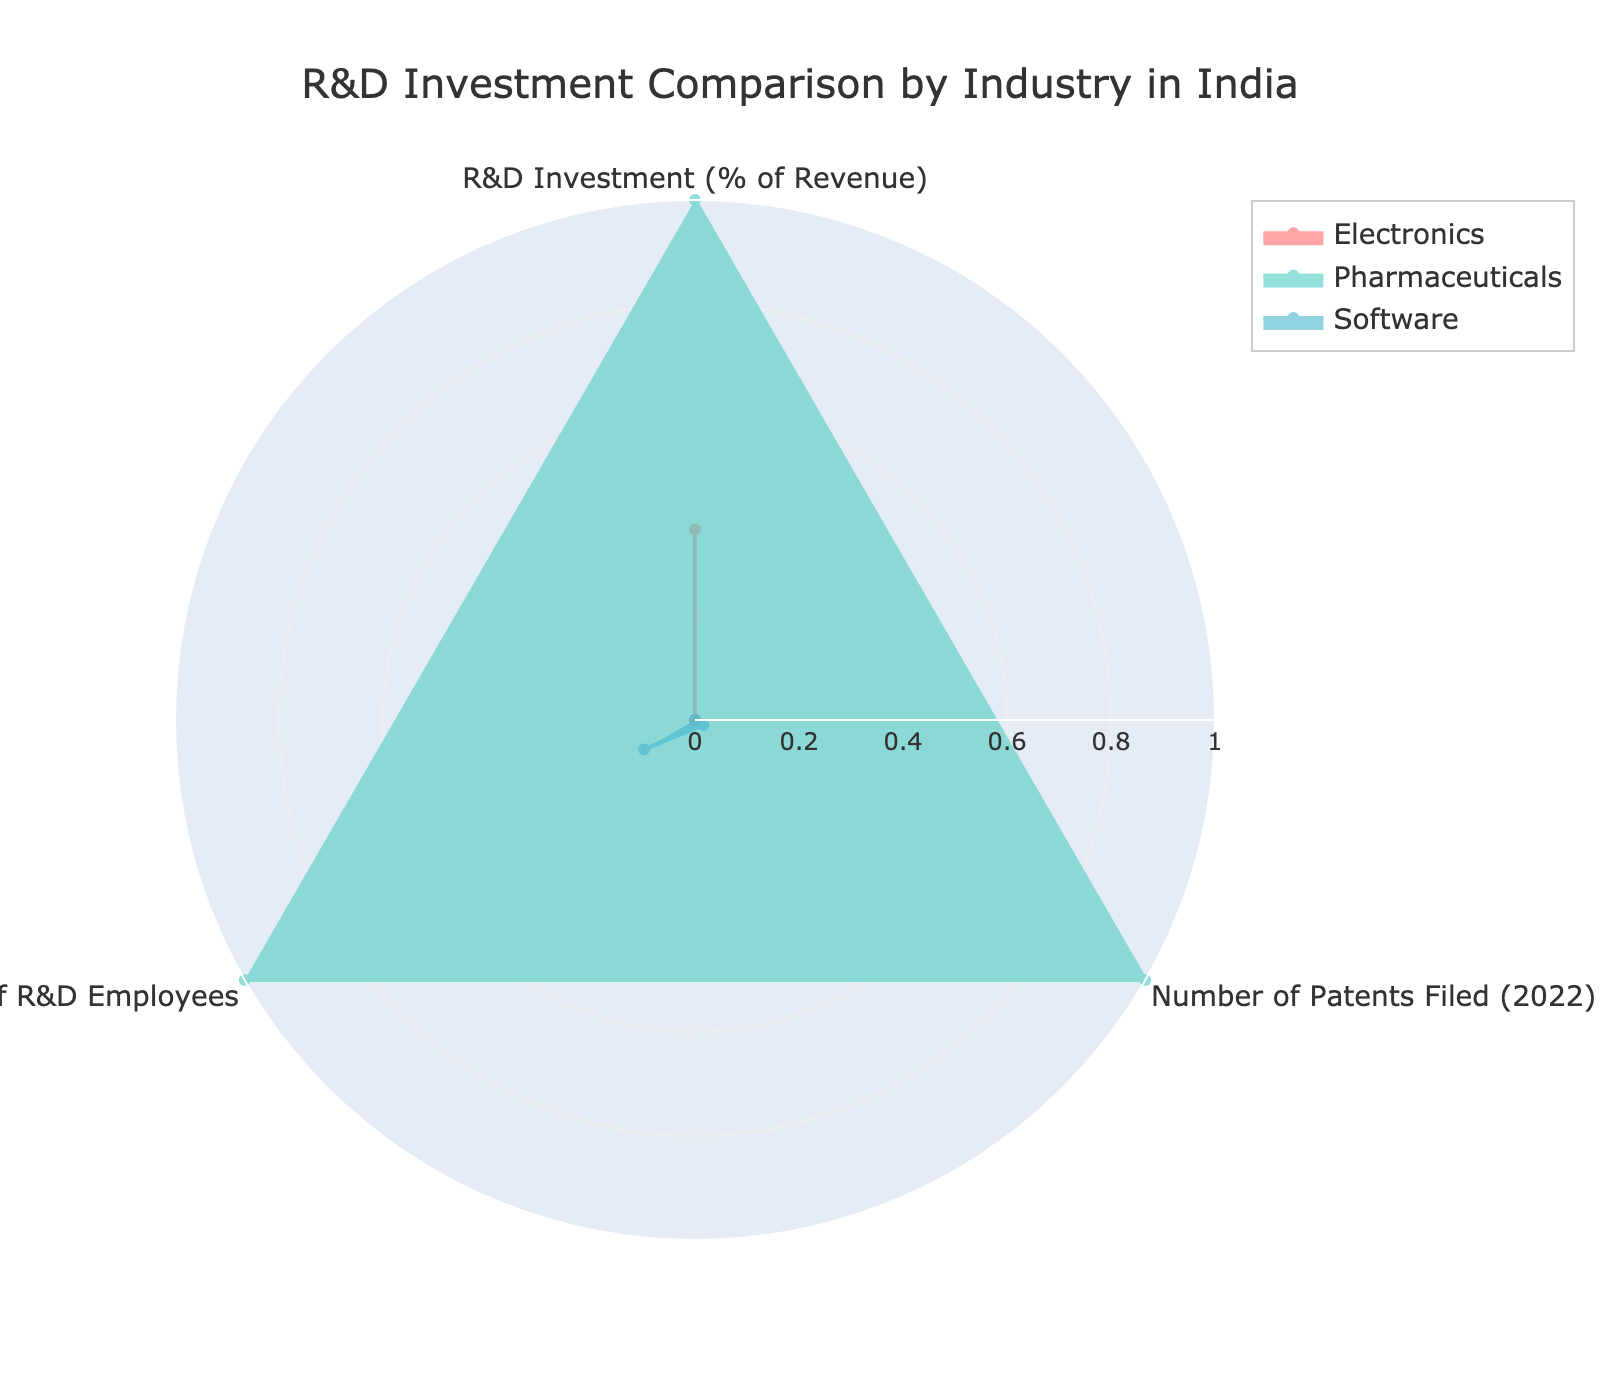What's the title of the radar chart? The radar chart's title is given at the top center of the figure. It reads 'R&D Investment Comparison by Industry in India'.
Answer: R&D Investment Comparison by Industry in India What are the three categories compared in the radar chart? The categories are labeled around the radar chart. They are 'R&D Investment (% of Revenue)', 'Number of Patents Filed (2022)', and 'Number of R&D Employees'.
Answer: R&D Investment (% of Revenue), Number of Patents Filed (2022), Number of R&D Employees Which industry shows the highest normalized value for 'R&D Investment (% of Revenue)'? By inspecting the radar chart, the 'Pharmaceuticals' polygon extends the furthest in the direction of 'R&D Investment (% of Revenue)', indicating the highest normalized value.
Answer: Pharmaceuticals Which industry has the lowest normalized value for 'Number of Patents Filed (2022)'? Observing the lengths of the polygons towards 'Number of Patents Filed (2022)', it is clear that the 'Software' industry has the shortest extension, indicating the lowest normalized value.
Answer: Software Order the industries from highest to lowest normalized value in 'Number of R&D Employees'. Examining the relative lengths of the polygons in the direction of 'Number of R&D Employees', they are ordered as follows: Pharmaceuticals, Software, Electronics.
Answer: Pharmaceuticals, Software, Electronics Which industry outperforms the others in more categories? By visually comparing the lengths of the polygons for all three categories, 'Pharmaceuticals' has the longest extensions in two out of the three categories, indicating it outperforms the others in more categories.
Answer: Pharmaceuticals Compare the normalized 'R&D Investment (% of Revenue)' between 'Software' and 'Electronics' industries. Which industry has a higher value and by how much? The polygon for 'Software' extends further than 'Electronics' in the direction of 'R&D Investment (% of Revenue)'. The difference can be perceived visually but requires the actual values to quantify; however, for normalized values, 'Software' evidently has a higher normalized value.
Answer: Software Which industry has the closest values across all three categories? By observing the radar chart, it becomes clear that 'Electronics' has relatively balanced extensions in all three categories, suggesting the closest values across these categories.
Answer: Electronics What can be inferred about the 'Software' industry regarding 'R&D Investment (% of Revenue)' compared to 'Number of Patents Filed (2022)'? The 'Software' industry shows a relatively high value for 'R&D Investment (% of Revenue)' but has a relatively low value for 'Number of Patents Filed (2022)', indicating that despite higher investment, fewer patents are filed comparatively.
Answer: Higher investment, fewer patents filed 